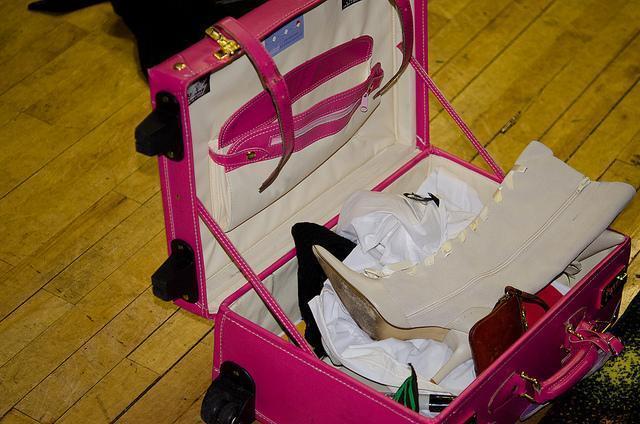How many pink storage bins are there?
Give a very brief answer. 1. 